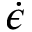Convert formula to latex. <formula><loc_0><loc_0><loc_500><loc_500>\dot { \epsilon }</formula> 